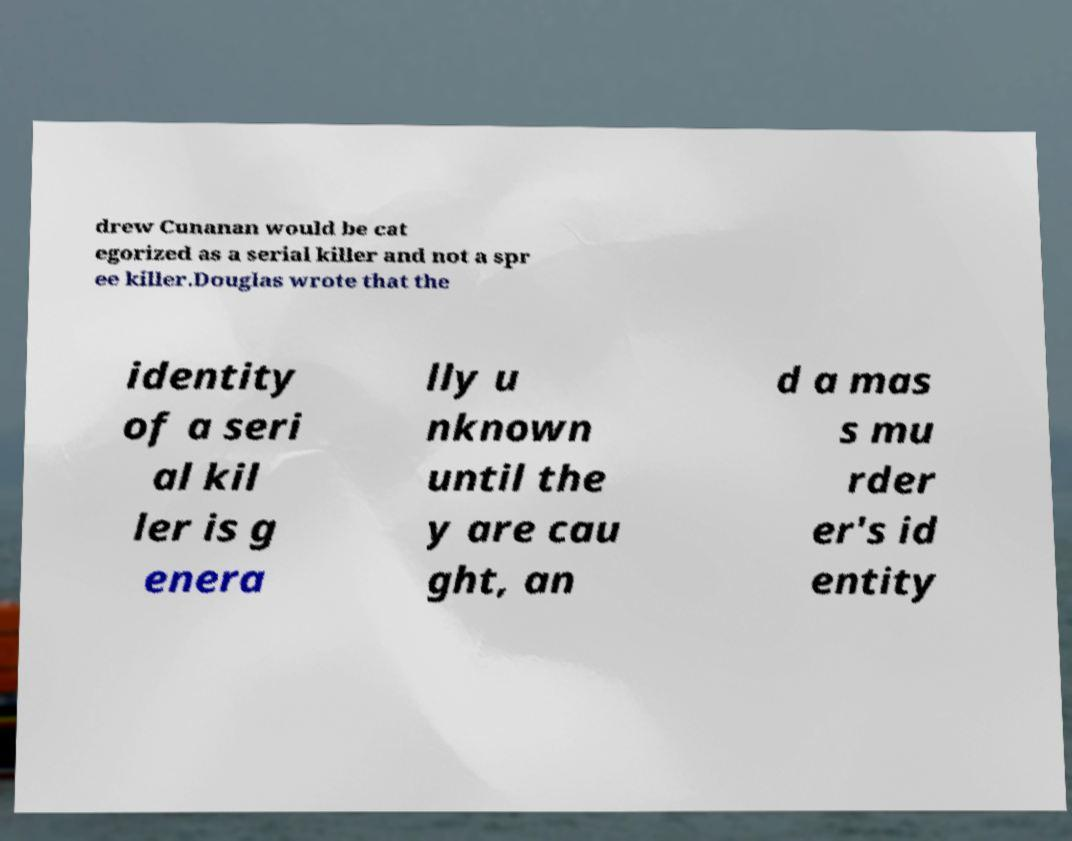Please read and relay the text visible in this image. What does it say? drew Cunanan would be cat egorized as a serial killer and not a spr ee killer.Douglas wrote that the identity of a seri al kil ler is g enera lly u nknown until the y are cau ght, an d a mas s mu rder er's id entity 